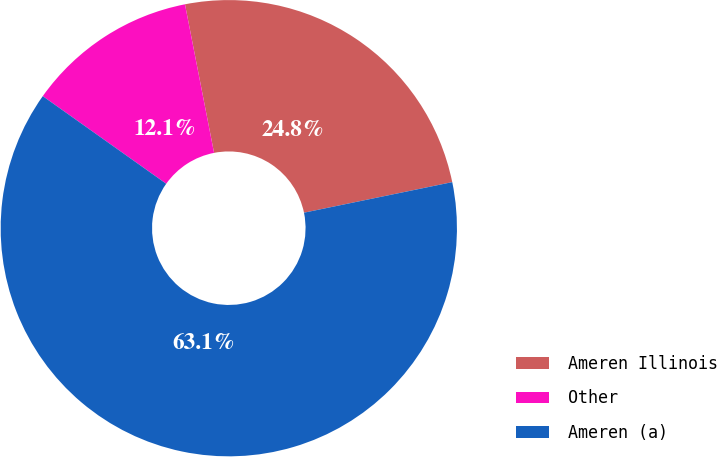Convert chart to OTSL. <chart><loc_0><loc_0><loc_500><loc_500><pie_chart><fcel>Ameren Illinois<fcel>Other<fcel>Ameren (a)<nl><fcel>24.84%<fcel>12.1%<fcel>63.06%<nl></chart> 